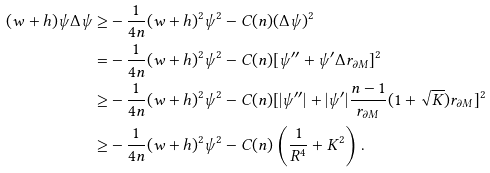Convert formula to latex. <formula><loc_0><loc_0><loc_500><loc_500>( w + h ) \psi \Delta \psi \geq & - \frac { 1 } { 4 n } ( w + h ) ^ { 2 } \psi ^ { 2 } - C ( n ) ( \Delta \psi ) ^ { 2 } \\ = & - \frac { 1 } { 4 n } ( w + h ) ^ { 2 } \psi ^ { 2 } - C ( n ) [ \psi ^ { \prime \prime } + \psi ^ { \prime } \Delta r _ { \partial M } ] ^ { 2 } \\ \geq & - \frac { 1 } { 4 n } ( w + h ) ^ { 2 } \psi ^ { 2 } - C ( n ) [ | \psi ^ { \prime \prime } | + | \psi ^ { \prime } | \frac { n - 1 } { r _ { \partial M } } ( 1 + \sqrt { K } ) r _ { \partial M } ] ^ { 2 } \\ \geq & - \frac { 1 } { 4 n } ( w + h ) ^ { 2 } \psi ^ { 2 } - C ( n ) \left ( \frac { 1 } { R ^ { 4 } } + K ^ { 2 } \right ) .</formula> 